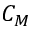Convert formula to latex. <formula><loc_0><loc_0><loc_500><loc_500>C _ { M }</formula> 